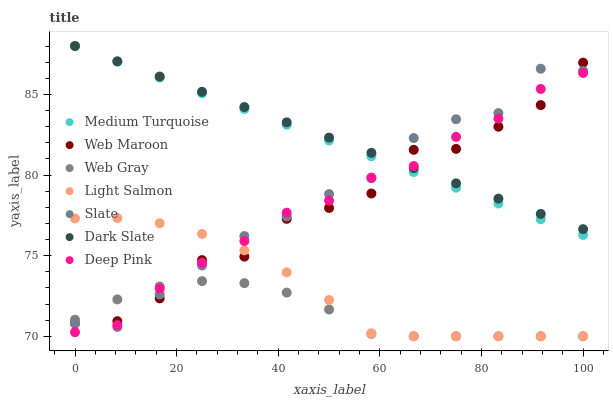Does Web Gray have the minimum area under the curve?
Answer yes or no. Yes. Does Dark Slate have the maximum area under the curve?
Answer yes or no. Yes. Does Slate have the minimum area under the curve?
Answer yes or no. No. Does Slate have the maximum area under the curve?
Answer yes or no. No. Is Dark Slate the smoothest?
Answer yes or no. Yes. Is Web Maroon the roughest?
Answer yes or no. Yes. Is Web Gray the smoothest?
Answer yes or no. No. Is Web Gray the roughest?
Answer yes or no. No. Does Light Salmon have the lowest value?
Answer yes or no. Yes. Does Slate have the lowest value?
Answer yes or no. No. Does Medium Turquoise have the highest value?
Answer yes or no. Yes. Does Slate have the highest value?
Answer yes or no. No. Is Light Salmon less than Medium Turquoise?
Answer yes or no. Yes. Is Dark Slate greater than Web Gray?
Answer yes or no. Yes. Does Web Maroon intersect Medium Turquoise?
Answer yes or no. Yes. Is Web Maroon less than Medium Turquoise?
Answer yes or no. No. Is Web Maroon greater than Medium Turquoise?
Answer yes or no. No. Does Light Salmon intersect Medium Turquoise?
Answer yes or no. No. 